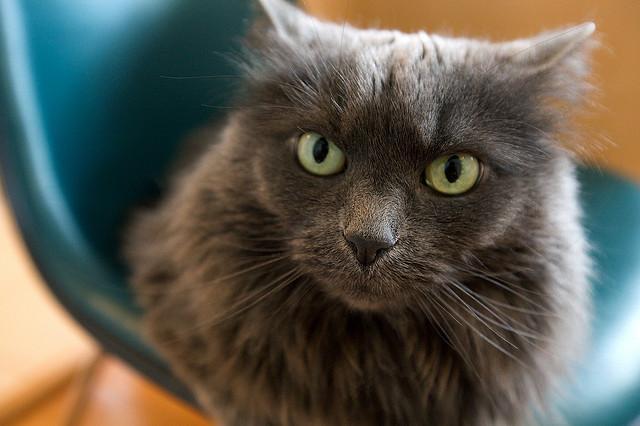How many cats are there?
Give a very brief answer. 1. How many chairs are in the photo?
Give a very brief answer. 1. How many people are on the stairs in the picture?
Give a very brief answer. 0. 